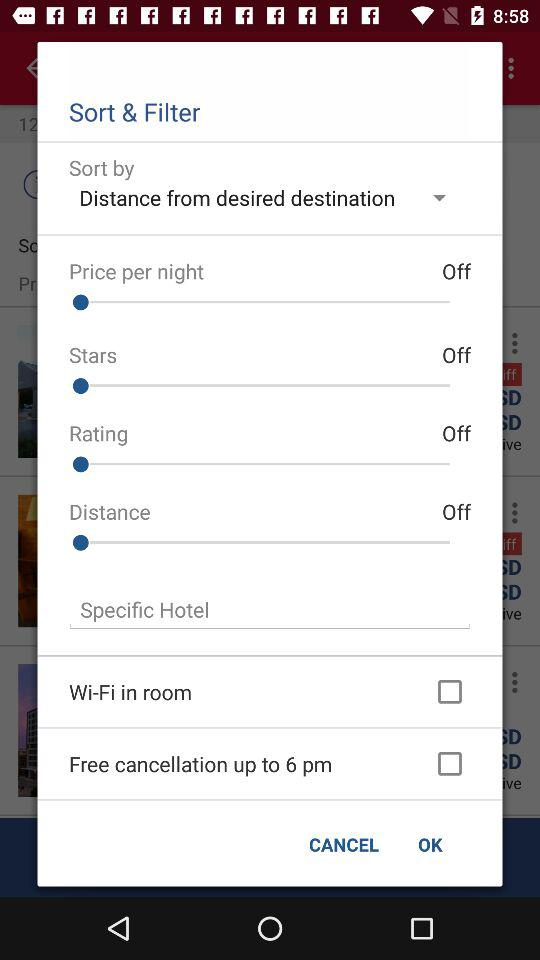What is status of "Price per night"? The status is "Off". 